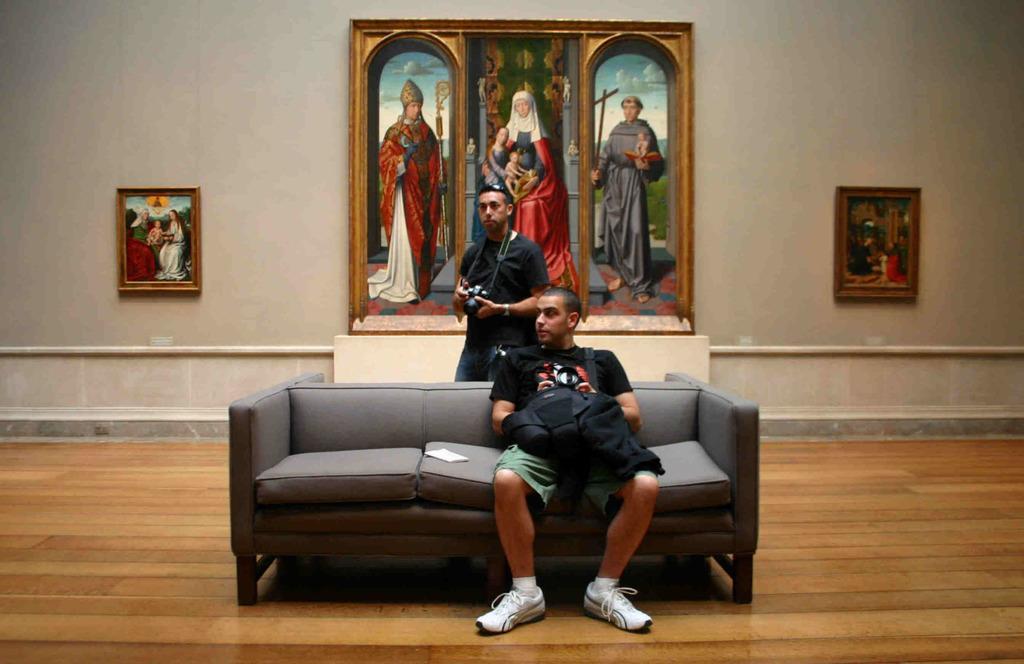Could you give a brief overview of what you see in this image? There is a person in black color t-shirt, sitting on a sofa. In the background, there is a person standing and holding a camera, these three images on the poster which is on the wall. Beside this poster, there are two posters. They are also on the wall. 